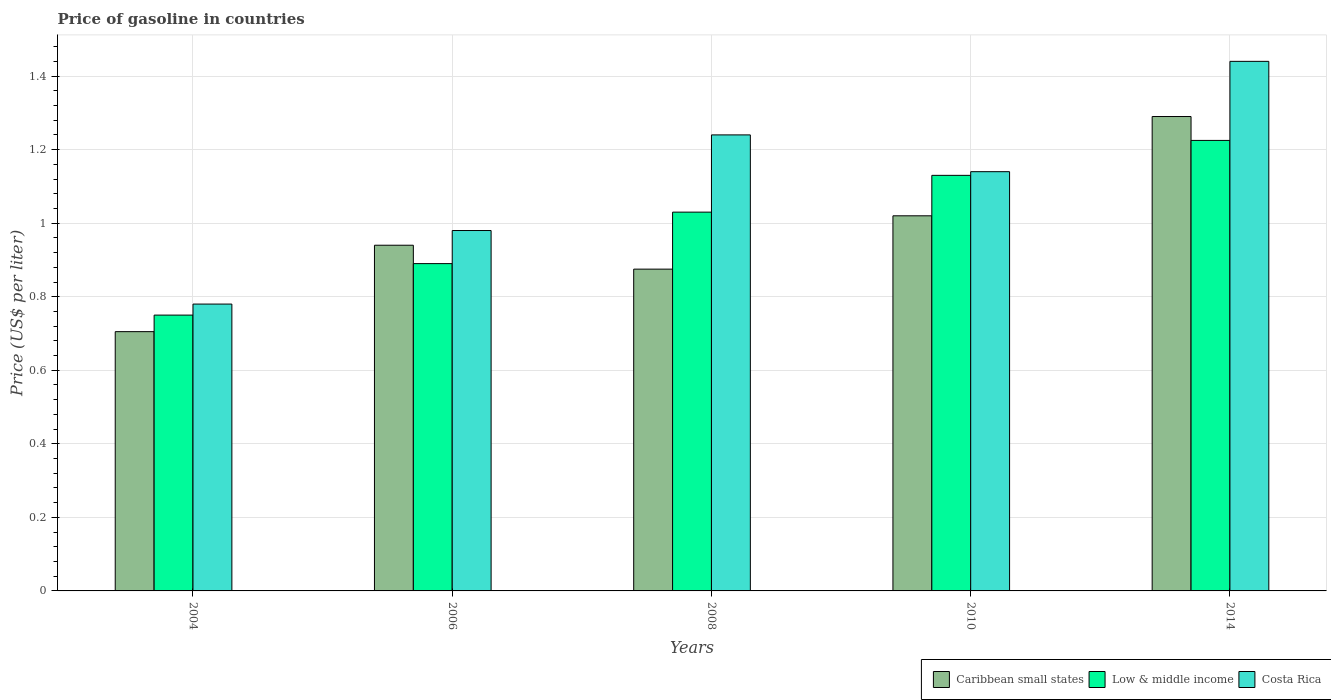How many different coloured bars are there?
Give a very brief answer. 3. Are the number of bars per tick equal to the number of legend labels?
Your answer should be compact. Yes. Are the number of bars on each tick of the X-axis equal?
Offer a terse response. Yes. What is the label of the 5th group of bars from the left?
Provide a short and direct response. 2014. What is the price of gasoline in Costa Rica in 2014?
Offer a terse response. 1.44. Across all years, what is the maximum price of gasoline in Costa Rica?
Provide a short and direct response. 1.44. What is the total price of gasoline in Low & middle income in the graph?
Keep it short and to the point. 5.03. What is the difference between the price of gasoline in Caribbean small states in 2004 and that in 2006?
Your answer should be compact. -0.23. What is the difference between the price of gasoline in Low & middle income in 2010 and the price of gasoline in Caribbean small states in 2014?
Give a very brief answer. -0.16. In the year 2008, what is the difference between the price of gasoline in Low & middle income and price of gasoline in Costa Rica?
Offer a very short reply. -0.21. In how many years, is the price of gasoline in Low & middle income greater than 0.48000000000000004 US$?
Give a very brief answer. 5. What is the ratio of the price of gasoline in Caribbean small states in 2006 to that in 2008?
Keep it short and to the point. 1.07. Is the price of gasoline in Caribbean small states in 2006 less than that in 2014?
Provide a short and direct response. Yes. What is the difference between the highest and the second highest price of gasoline in Costa Rica?
Offer a terse response. 0.2. What is the difference between the highest and the lowest price of gasoline in Low & middle income?
Give a very brief answer. 0.48. In how many years, is the price of gasoline in Costa Rica greater than the average price of gasoline in Costa Rica taken over all years?
Offer a terse response. 3. Is the sum of the price of gasoline in Costa Rica in 2006 and 2008 greater than the maximum price of gasoline in Low & middle income across all years?
Your answer should be compact. Yes. What does the 2nd bar from the left in 2008 represents?
Keep it short and to the point. Low & middle income. What does the 2nd bar from the right in 2006 represents?
Give a very brief answer. Low & middle income. Are the values on the major ticks of Y-axis written in scientific E-notation?
Your answer should be compact. No. Does the graph contain any zero values?
Make the answer very short. No. How many legend labels are there?
Give a very brief answer. 3. What is the title of the graph?
Provide a short and direct response. Price of gasoline in countries. Does "Central Europe" appear as one of the legend labels in the graph?
Ensure brevity in your answer.  No. What is the label or title of the X-axis?
Your response must be concise. Years. What is the label or title of the Y-axis?
Your answer should be very brief. Price (US$ per liter). What is the Price (US$ per liter) in Caribbean small states in 2004?
Offer a very short reply. 0.7. What is the Price (US$ per liter) of Low & middle income in 2004?
Your answer should be compact. 0.75. What is the Price (US$ per liter) of Costa Rica in 2004?
Keep it short and to the point. 0.78. What is the Price (US$ per liter) of Low & middle income in 2006?
Make the answer very short. 0.89. What is the Price (US$ per liter) in Costa Rica in 2006?
Your answer should be very brief. 0.98. What is the Price (US$ per liter) of Costa Rica in 2008?
Provide a short and direct response. 1.24. What is the Price (US$ per liter) of Low & middle income in 2010?
Offer a terse response. 1.13. What is the Price (US$ per liter) in Costa Rica in 2010?
Keep it short and to the point. 1.14. What is the Price (US$ per liter) of Caribbean small states in 2014?
Provide a short and direct response. 1.29. What is the Price (US$ per liter) in Low & middle income in 2014?
Give a very brief answer. 1.23. What is the Price (US$ per liter) in Costa Rica in 2014?
Provide a short and direct response. 1.44. Across all years, what is the maximum Price (US$ per liter) of Caribbean small states?
Provide a short and direct response. 1.29. Across all years, what is the maximum Price (US$ per liter) of Low & middle income?
Provide a succinct answer. 1.23. Across all years, what is the maximum Price (US$ per liter) of Costa Rica?
Offer a very short reply. 1.44. Across all years, what is the minimum Price (US$ per liter) in Caribbean small states?
Your answer should be very brief. 0.7. Across all years, what is the minimum Price (US$ per liter) in Costa Rica?
Your response must be concise. 0.78. What is the total Price (US$ per liter) in Caribbean small states in the graph?
Give a very brief answer. 4.83. What is the total Price (US$ per liter) in Low & middle income in the graph?
Provide a succinct answer. 5.03. What is the total Price (US$ per liter) in Costa Rica in the graph?
Your answer should be very brief. 5.58. What is the difference between the Price (US$ per liter) of Caribbean small states in 2004 and that in 2006?
Make the answer very short. -0.23. What is the difference between the Price (US$ per liter) in Low & middle income in 2004 and that in 2006?
Your answer should be compact. -0.14. What is the difference between the Price (US$ per liter) in Caribbean small states in 2004 and that in 2008?
Offer a very short reply. -0.17. What is the difference between the Price (US$ per liter) in Low & middle income in 2004 and that in 2008?
Offer a terse response. -0.28. What is the difference between the Price (US$ per liter) of Costa Rica in 2004 and that in 2008?
Offer a very short reply. -0.46. What is the difference between the Price (US$ per liter) of Caribbean small states in 2004 and that in 2010?
Make the answer very short. -0.32. What is the difference between the Price (US$ per liter) in Low & middle income in 2004 and that in 2010?
Keep it short and to the point. -0.38. What is the difference between the Price (US$ per liter) in Costa Rica in 2004 and that in 2010?
Your response must be concise. -0.36. What is the difference between the Price (US$ per liter) of Caribbean small states in 2004 and that in 2014?
Provide a short and direct response. -0.58. What is the difference between the Price (US$ per liter) of Low & middle income in 2004 and that in 2014?
Your answer should be compact. -0.47. What is the difference between the Price (US$ per liter) of Costa Rica in 2004 and that in 2014?
Make the answer very short. -0.66. What is the difference between the Price (US$ per liter) of Caribbean small states in 2006 and that in 2008?
Give a very brief answer. 0.07. What is the difference between the Price (US$ per liter) of Low & middle income in 2006 and that in 2008?
Give a very brief answer. -0.14. What is the difference between the Price (US$ per liter) in Costa Rica in 2006 and that in 2008?
Your response must be concise. -0.26. What is the difference between the Price (US$ per liter) in Caribbean small states in 2006 and that in 2010?
Provide a succinct answer. -0.08. What is the difference between the Price (US$ per liter) in Low & middle income in 2006 and that in 2010?
Your response must be concise. -0.24. What is the difference between the Price (US$ per liter) in Costa Rica in 2006 and that in 2010?
Provide a succinct answer. -0.16. What is the difference between the Price (US$ per liter) of Caribbean small states in 2006 and that in 2014?
Provide a short and direct response. -0.35. What is the difference between the Price (US$ per liter) of Low & middle income in 2006 and that in 2014?
Give a very brief answer. -0.34. What is the difference between the Price (US$ per liter) in Costa Rica in 2006 and that in 2014?
Provide a short and direct response. -0.46. What is the difference between the Price (US$ per liter) in Caribbean small states in 2008 and that in 2010?
Keep it short and to the point. -0.14. What is the difference between the Price (US$ per liter) in Costa Rica in 2008 and that in 2010?
Keep it short and to the point. 0.1. What is the difference between the Price (US$ per liter) in Caribbean small states in 2008 and that in 2014?
Offer a very short reply. -0.41. What is the difference between the Price (US$ per liter) in Low & middle income in 2008 and that in 2014?
Offer a terse response. -0.2. What is the difference between the Price (US$ per liter) of Costa Rica in 2008 and that in 2014?
Offer a very short reply. -0.2. What is the difference between the Price (US$ per liter) in Caribbean small states in 2010 and that in 2014?
Keep it short and to the point. -0.27. What is the difference between the Price (US$ per liter) of Low & middle income in 2010 and that in 2014?
Provide a succinct answer. -0.1. What is the difference between the Price (US$ per liter) in Caribbean small states in 2004 and the Price (US$ per liter) in Low & middle income in 2006?
Your answer should be compact. -0.18. What is the difference between the Price (US$ per liter) of Caribbean small states in 2004 and the Price (US$ per liter) of Costa Rica in 2006?
Your answer should be very brief. -0.28. What is the difference between the Price (US$ per liter) in Low & middle income in 2004 and the Price (US$ per liter) in Costa Rica in 2006?
Make the answer very short. -0.23. What is the difference between the Price (US$ per liter) in Caribbean small states in 2004 and the Price (US$ per liter) in Low & middle income in 2008?
Ensure brevity in your answer.  -0.33. What is the difference between the Price (US$ per liter) in Caribbean small states in 2004 and the Price (US$ per liter) in Costa Rica in 2008?
Provide a short and direct response. -0.54. What is the difference between the Price (US$ per liter) in Low & middle income in 2004 and the Price (US$ per liter) in Costa Rica in 2008?
Offer a very short reply. -0.49. What is the difference between the Price (US$ per liter) in Caribbean small states in 2004 and the Price (US$ per liter) in Low & middle income in 2010?
Provide a short and direct response. -0.42. What is the difference between the Price (US$ per liter) of Caribbean small states in 2004 and the Price (US$ per liter) of Costa Rica in 2010?
Provide a short and direct response. -0.43. What is the difference between the Price (US$ per liter) of Low & middle income in 2004 and the Price (US$ per liter) of Costa Rica in 2010?
Keep it short and to the point. -0.39. What is the difference between the Price (US$ per liter) in Caribbean small states in 2004 and the Price (US$ per liter) in Low & middle income in 2014?
Your response must be concise. -0.52. What is the difference between the Price (US$ per liter) of Caribbean small states in 2004 and the Price (US$ per liter) of Costa Rica in 2014?
Make the answer very short. -0.73. What is the difference between the Price (US$ per liter) of Low & middle income in 2004 and the Price (US$ per liter) of Costa Rica in 2014?
Keep it short and to the point. -0.69. What is the difference between the Price (US$ per liter) of Caribbean small states in 2006 and the Price (US$ per liter) of Low & middle income in 2008?
Provide a succinct answer. -0.09. What is the difference between the Price (US$ per liter) in Caribbean small states in 2006 and the Price (US$ per liter) in Costa Rica in 2008?
Give a very brief answer. -0.3. What is the difference between the Price (US$ per liter) in Low & middle income in 2006 and the Price (US$ per liter) in Costa Rica in 2008?
Make the answer very short. -0.35. What is the difference between the Price (US$ per liter) in Caribbean small states in 2006 and the Price (US$ per liter) in Low & middle income in 2010?
Make the answer very short. -0.19. What is the difference between the Price (US$ per liter) in Caribbean small states in 2006 and the Price (US$ per liter) in Costa Rica in 2010?
Your response must be concise. -0.2. What is the difference between the Price (US$ per liter) in Low & middle income in 2006 and the Price (US$ per liter) in Costa Rica in 2010?
Ensure brevity in your answer.  -0.25. What is the difference between the Price (US$ per liter) of Caribbean small states in 2006 and the Price (US$ per liter) of Low & middle income in 2014?
Ensure brevity in your answer.  -0.28. What is the difference between the Price (US$ per liter) of Caribbean small states in 2006 and the Price (US$ per liter) of Costa Rica in 2014?
Provide a succinct answer. -0.5. What is the difference between the Price (US$ per liter) of Low & middle income in 2006 and the Price (US$ per liter) of Costa Rica in 2014?
Your response must be concise. -0.55. What is the difference between the Price (US$ per liter) in Caribbean small states in 2008 and the Price (US$ per liter) in Low & middle income in 2010?
Your response must be concise. -0.26. What is the difference between the Price (US$ per liter) of Caribbean small states in 2008 and the Price (US$ per liter) of Costa Rica in 2010?
Keep it short and to the point. -0.27. What is the difference between the Price (US$ per liter) in Low & middle income in 2008 and the Price (US$ per liter) in Costa Rica in 2010?
Provide a succinct answer. -0.11. What is the difference between the Price (US$ per liter) in Caribbean small states in 2008 and the Price (US$ per liter) in Low & middle income in 2014?
Offer a terse response. -0.35. What is the difference between the Price (US$ per liter) of Caribbean small states in 2008 and the Price (US$ per liter) of Costa Rica in 2014?
Give a very brief answer. -0.56. What is the difference between the Price (US$ per liter) in Low & middle income in 2008 and the Price (US$ per liter) in Costa Rica in 2014?
Your response must be concise. -0.41. What is the difference between the Price (US$ per liter) in Caribbean small states in 2010 and the Price (US$ per liter) in Low & middle income in 2014?
Ensure brevity in your answer.  -0.2. What is the difference between the Price (US$ per liter) of Caribbean small states in 2010 and the Price (US$ per liter) of Costa Rica in 2014?
Your response must be concise. -0.42. What is the difference between the Price (US$ per liter) of Low & middle income in 2010 and the Price (US$ per liter) of Costa Rica in 2014?
Make the answer very short. -0.31. What is the average Price (US$ per liter) in Costa Rica per year?
Your response must be concise. 1.12. In the year 2004, what is the difference between the Price (US$ per liter) in Caribbean small states and Price (US$ per liter) in Low & middle income?
Provide a short and direct response. -0.04. In the year 2004, what is the difference between the Price (US$ per liter) in Caribbean small states and Price (US$ per liter) in Costa Rica?
Ensure brevity in your answer.  -0.07. In the year 2004, what is the difference between the Price (US$ per liter) in Low & middle income and Price (US$ per liter) in Costa Rica?
Keep it short and to the point. -0.03. In the year 2006, what is the difference between the Price (US$ per liter) in Caribbean small states and Price (US$ per liter) in Low & middle income?
Your answer should be very brief. 0.05. In the year 2006, what is the difference between the Price (US$ per liter) of Caribbean small states and Price (US$ per liter) of Costa Rica?
Your answer should be very brief. -0.04. In the year 2006, what is the difference between the Price (US$ per liter) of Low & middle income and Price (US$ per liter) of Costa Rica?
Keep it short and to the point. -0.09. In the year 2008, what is the difference between the Price (US$ per liter) in Caribbean small states and Price (US$ per liter) in Low & middle income?
Your response must be concise. -0.15. In the year 2008, what is the difference between the Price (US$ per liter) of Caribbean small states and Price (US$ per liter) of Costa Rica?
Make the answer very short. -0.36. In the year 2008, what is the difference between the Price (US$ per liter) in Low & middle income and Price (US$ per liter) in Costa Rica?
Provide a succinct answer. -0.21. In the year 2010, what is the difference between the Price (US$ per liter) of Caribbean small states and Price (US$ per liter) of Low & middle income?
Your response must be concise. -0.11. In the year 2010, what is the difference between the Price (US$ per liter) of Caribbean small states and Price (US$ per liter) of Costa Rica?
Your answer should be very brief. -0.12. In the year 2010, what is the difference between the Price (US$ per liter) of Low & middle income and Price (US$ per liter) of Costa Rica?
Your response must be concise. -0.01. In the year 2014, what is the difference between the Price (US$ per liter) in Caribbean small states and Price (US$ per liter) in Low & middle income?
Provide a short and direct response. 0.07. In the year 2014, what is the difference between the Price (US$ per liter) in Low & middle income and Price (US$ per liter) in Costa Rica?
Offer a very short reply. -0.21. What is the ratio of the Price (US$ per liter) of Caribbean small states in 2004 to that in 2006?
Your answer should be very brief. 0.75. What is the ratio of the Price (US$ per liter) of Low & middle income in 2004 to that in 2006?
Your answer should be compact. 0.84. What is the ratio of the Price (US$ per liter) of Costa Rica in 2004 to that in 2006?
Make the answer very short. 0.8. What is the ratio of the Price (US$ per liter) of Caribbean small states in 2004 to that in 2008?
Provide a succinct answer. 0.81. What is the ratio of the Price (US$ per liter) of Low & middle income in 2004 to that in 2008?
Provide a short and direct response. 0.73. What is the ratio of the Price (US$ per liter) in Costa Rica in 2004 to that in 2008?
Provide a short and direct response. 0.63. What is the ratio of the Price (US$ per liter) of Caribbean small states in 2004 to that in 2010?
Ensure brevity in your answer.  0.69. What is the ratio of the Price (US$ per liter) of Low & middle income in 2004 to that in 2010?
Provide a succinct answer. 0.66. What is the ratio of the Price (US$ per liter) of Costa Rica in 2004 to that in 2010?
Provide a short and direct response. 0.68. What is the ratio of the Price (US$ per liter) in Caribbean small states in 2004 to that in 2014?
Keep it short and to the point. 0.55. What is the ratio of the Price (US$ per liter) in Low & middle income in 2004 to that in 2014?
Ensure brevity in your answer.  0.61. What is the ratio of the Price (US$ per liter) of Costa Rica in 2004 to that in 2014?
Give a very brief answer. 0.54. What is the ratio of the Price (US$ per liter) of Caribbean small states in 2006 to that in 2008?
Ensure brevity in your answer.  1.07. What is the ratio of the Price (US$ per liter) in Low & middle income in 2006 to that in 2008?
Keep it short and to the point. 0.86. What is the ratio of the Price (US$ per liter) of Costa Rica in 2006 to that in 2008?
Provide a succinct answer. 0.79. What is the ratio of the Price (US$ per liter) in Caribbean small states in 2006 to that in 2010?
Ensure brevity in your answer.  0.92. What is the ratio of the Price (US$ per liter) of Low & middle income in 2006 to that in 2010?
Make the answer very short. 0.79. What is the ratio of the Price (US$ per liter) in Costa Rica in 2006 to that in 2010?
Make the answer very short. 0.86. What is the ratio of the Price (US$ per liter) in Caribbean small states in 2006 to that in 2014?
Your answer should be compact. 0.73. What is the ratio of the Price (US$ per liter) of Low & middle income in 2006 to that in 2014?
Make the answer very short. 0.73. What is the ratio of the Price (US$ per liter) in Costa Rica in 2006 to that in 2014?
Provide a succinct answer. 0.68. What is the ratio of the Price (US$ per liter) of Caribbean small states in 2008 to that in 2010?
Offer a very short reply. 0.86. What is the ratio of the Price (US$ per liter) in Low & middle income in 2008 to that in 2010?
Give a very brief answer. 0.91. What is the ratio of the Price (US$ per liter) of Costa Rica in 2008 to that in 2010?
Your answer should be very brief. 1.09. What is the ratio of the Price (US$ per liter) of Caribbean small states in 2008 to that in 2014?
Keep it short and to the point. 0.68. What is the ratio of the Price (US$ per liter) in Low & middle income in 2008 to that in 2014?
Make the answer very short. 0.84. What is the ratio of the Price (US$ per liter) of Costa Rica in 2008 to that in 2014?
Your answer should be compact. 0.86. What is the ratio of the Price (US$ per liter) in Caribbean small states in 2010 to that in 2014?
Ensure brevity in your answer.  0.79. What is the ratio of the Price (US$ per liter) in Low & middle income in 2010 to that in 2014?
Make the answer very short. 0.92. What is the ratio of the Price (US$ per liter) in Costa Rica in 2010 to that in 2014?
Make the answer very short. 0.79. What is the difference between the highest and the second highest Price (US$ per liter) in Caribbean small states?
Provide a short and direct response. 0.27. What is the difference between the highest and the second highest Price (US$ per liter) in Low & middle income?
Make the answer very short. 0.1. What is the difference between the highest and the second highest Price (US$ per liter) in Costa Rica?
Provide a succinct answer. 0.2. What is the difference between the highest and the lowest Price (US$ per liter) of Caribbean small states?
Ensure brevity in your answer.  0.58. What is the difference between the highest and the lowest Price (US$ per liter) of Low & middle income?
Offer a terse response. 0.47. What is the difference between the highest and the lowest Price (US$ per liter) in Costa Rica?
Provide a succinct answer. 0.66. 